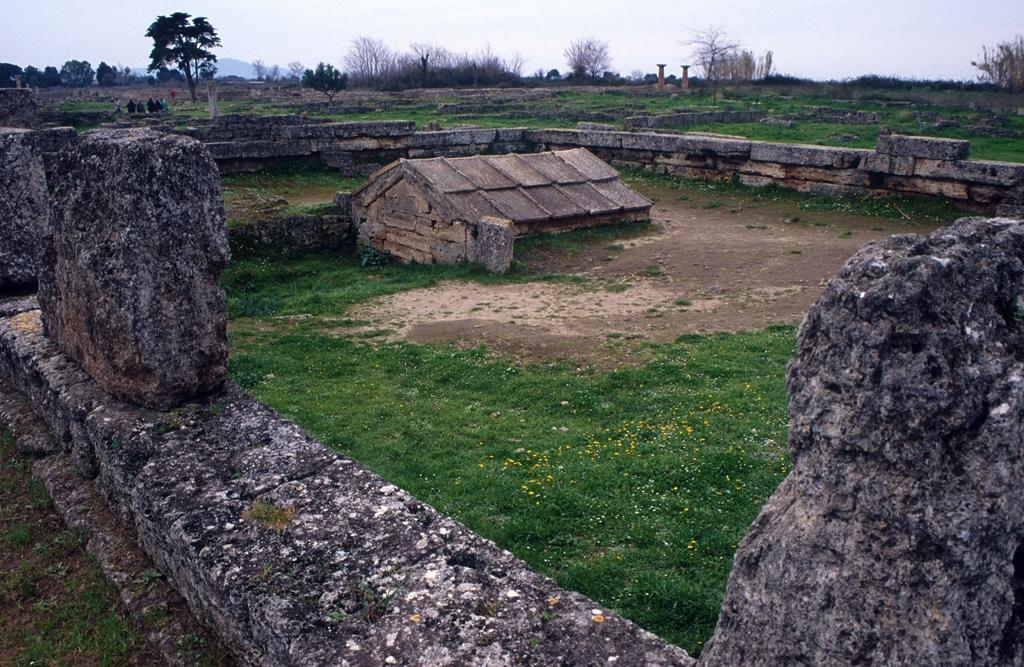What type of house is in the image? There is a wooden house in the image. What can be seen on the ground in the image? There is grass visible in the image. What architectural feature is present in the image? There is a wall in the image. What type of natural elements are present in the image? There are rocks and trees in the image. What is visible in the background of the image? The sky is visible in the background of the image. What type of language is being spoken by the trees in the background of the image? There is no indication in the image that the trees are speaking any language. 